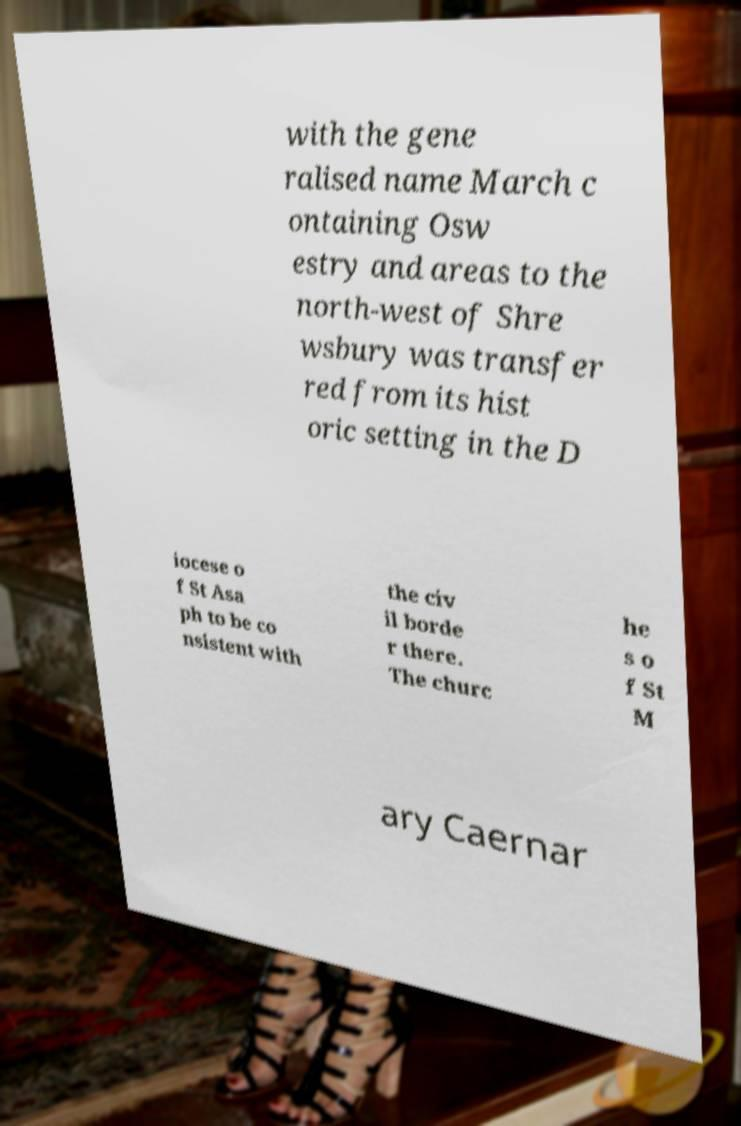Could you assist in decoding the text presented in this image and type it out clearly? with the gene ralised name March c ontaining Osw estry and areas to the north-west of Shre wsbury was transfer red from its hist oric setting in the D iocese o f St Asa ph to be co nsistent with the civ il borde r there. The churc he s o f St M ary Caernar 